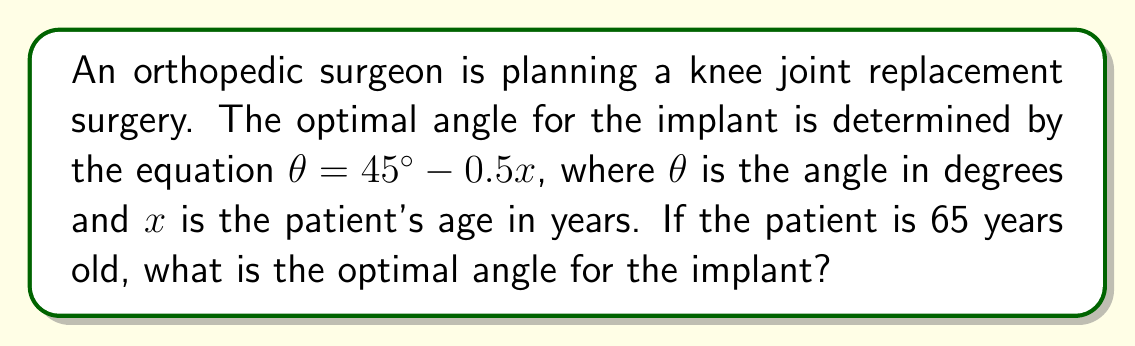Give your solution to this math problem. 1. We are given the equation: $\theta = 45^\circ - 0.5x$
   Where $\theta$ is the optimal angle in degrees and $x$ is the patient's age in years.

2. We know the patient's age: $x = 65$ years

3. Let's substitute this value into the equation:
   $\theta = 45^\circ - 0.5(65)$

4. Simplify the right side of the equation:
   $\theta = 45^\circ - 32.5^\circ$

5. Perform the subtraction:
   $\theta = 12.5^\circ$

Therefore, the optimal angle for the joint replacement implant for this 65-year-old patient is 12.5 degrees.
Answer: $12.5^\circ$ 